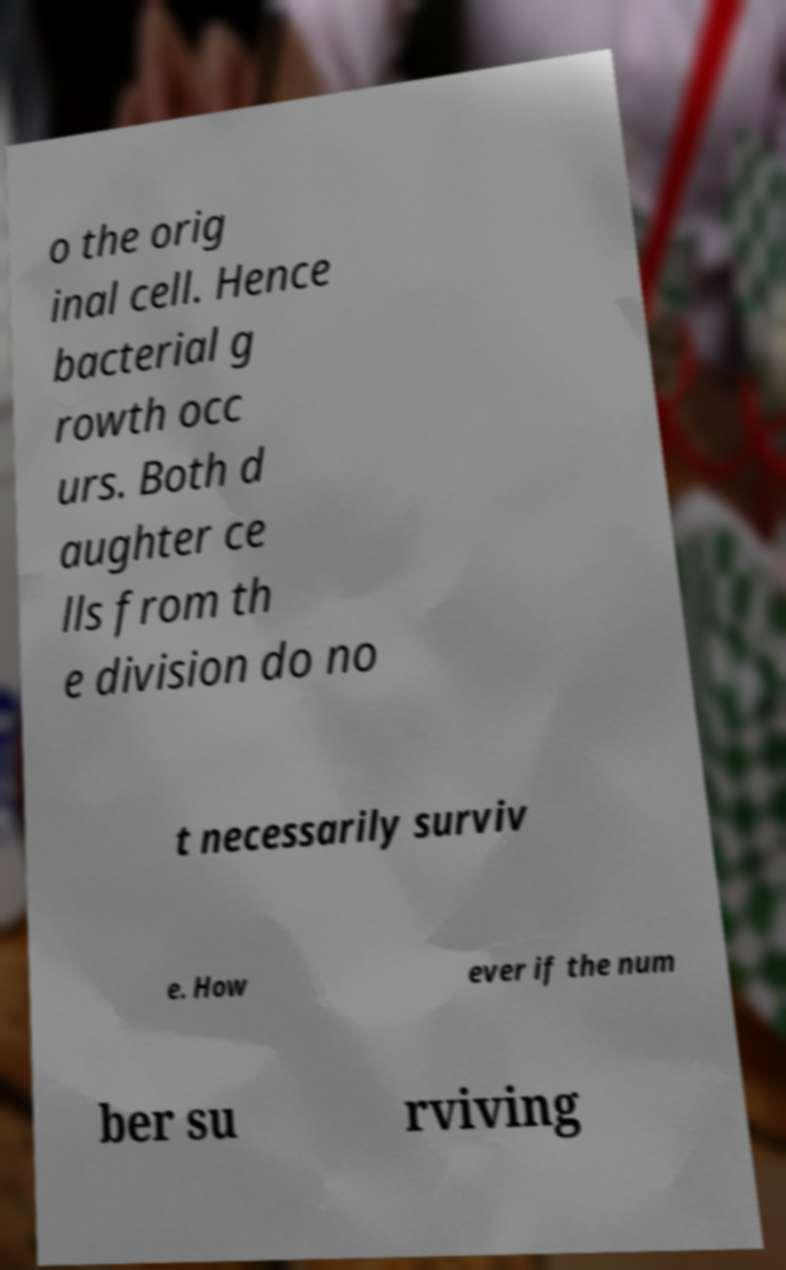What messages or text are displayed in this image? I need them in a readable, typed format. o the orig inal cell. Hence bacterial g rowth occ urs. Both d aughter ce lls from th e division do no t necessarily surviv e. How ever if the num ber su rviving 